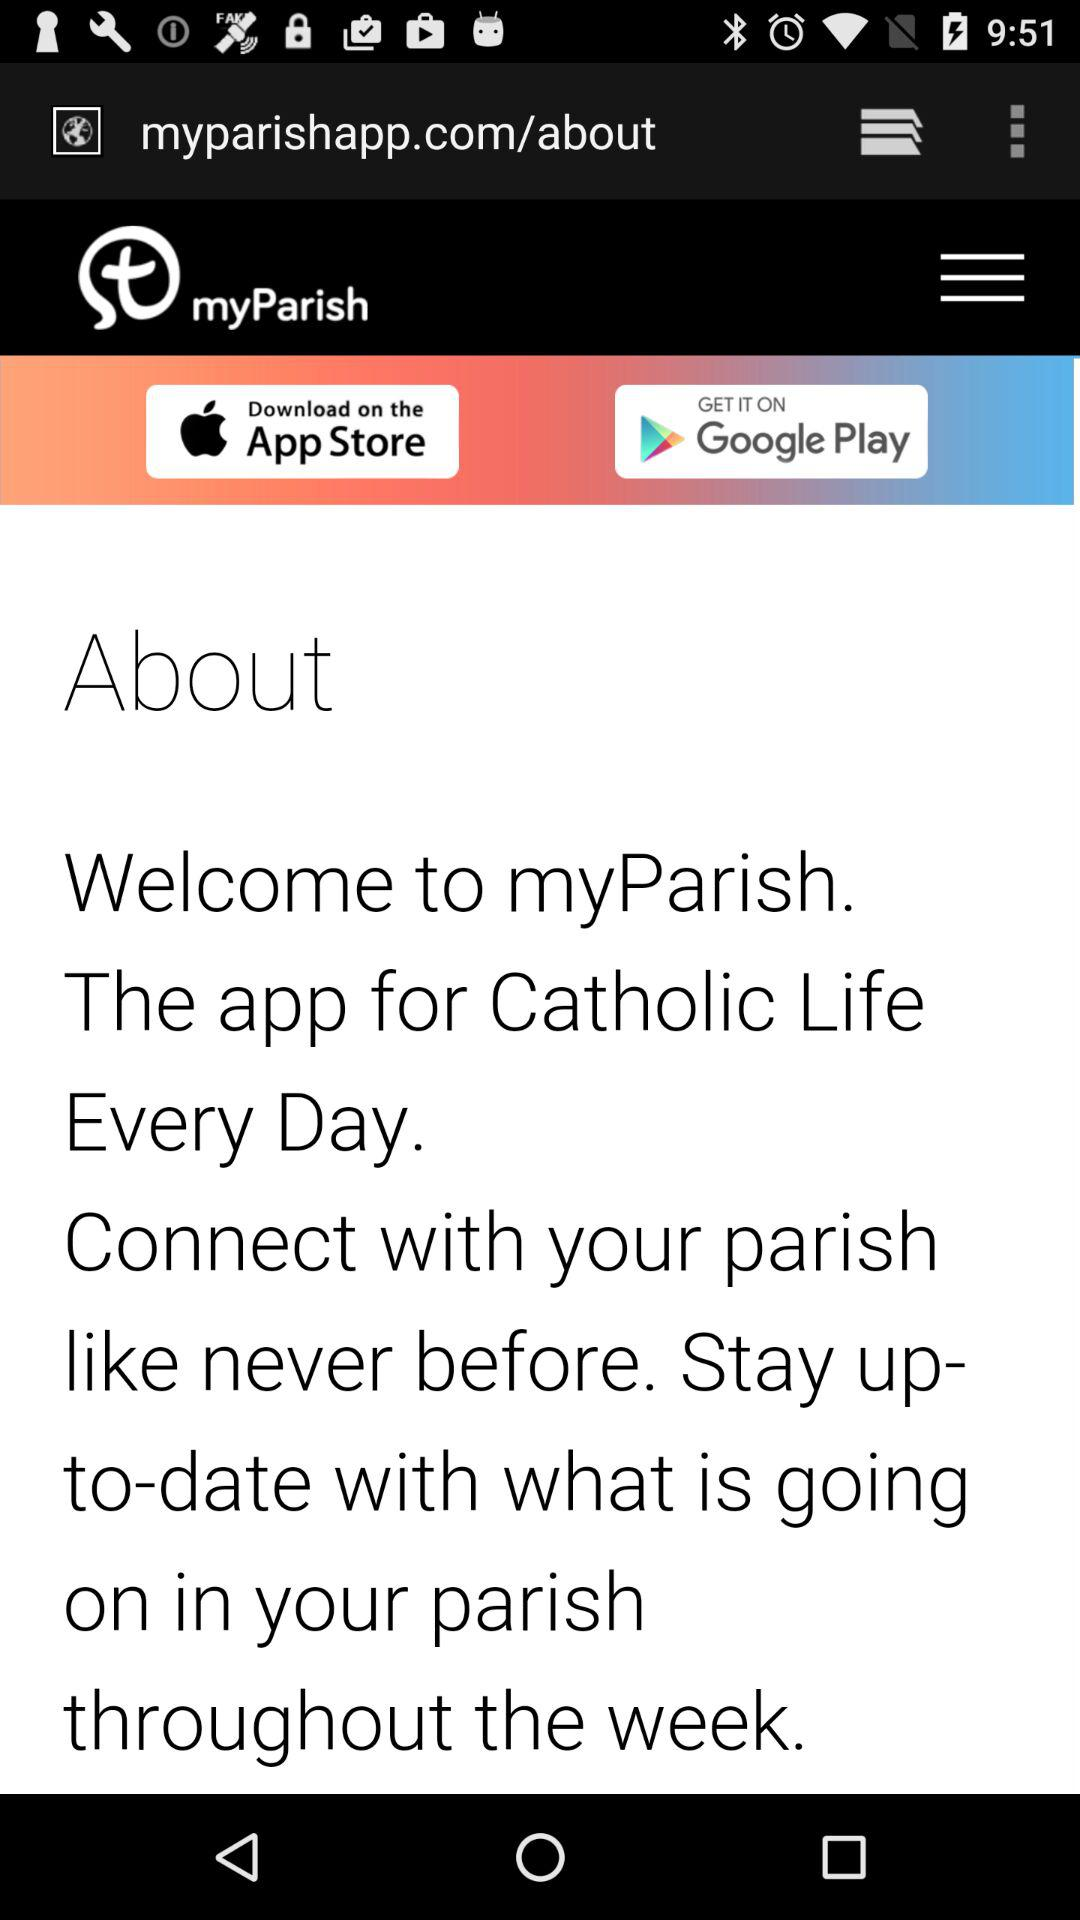What is the name of the application? The name of the application is "myParish". 